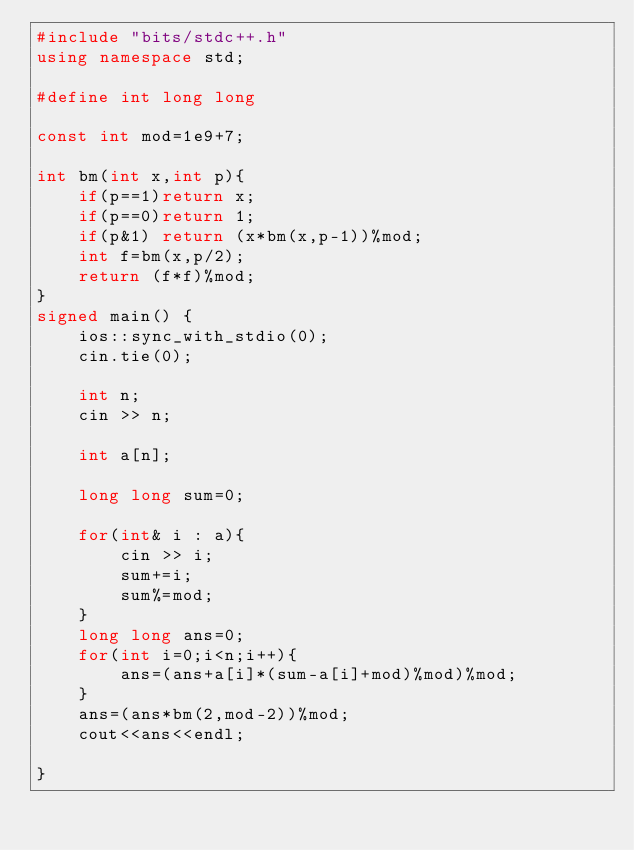Convert code to text. <code><loc_0><loc_0><loc_500><loc_500><_C++_>#include "bits/stdc++.h"
using namespace std;

#define int long long 

const int mod=1e9+7;

int bm(int x,int p){
    if(p==1)return x;
    if(p==0)return 1;
    if(p&1) return (x*bm(x,p-1))%mod;
    int f=bm(x,p/2);
    return (f*f)%mod;
}
signed main() {
    ios::sync_with_stdio(0);
    cin.tie(0);

    int n;
    cin >> n;

    int a[n];

    long long sum=0;

    for(int& i : a){
        cin >> i;
        sum+=i;
        sum%=mod;
    }
    long long ans=0;
    for(int i=0;i<n;i++){
        ans=(ans+a[i]*(sum-a[i]+mod)%mod)%mod;
    }
    ans=(ans*bm(2,mod-2))%mod;
    cout<<ans<<endl;

}

</code> 